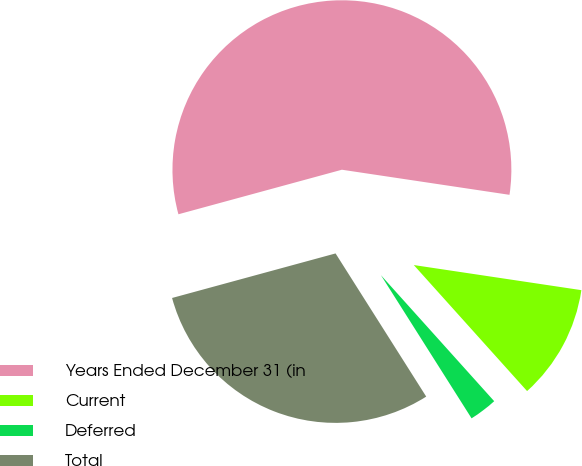Convert chart. <chart><loc_0><loc_0><loc_500><loc_500><pie_chart><fcel>Years Ended December 31 (in<fcel>Current<fcel>Deferred<fcel>Total<nl><fcel>56.6%<fcel>10.98%<fcel>2.67%<fcel>29.75%<nl></chart> 